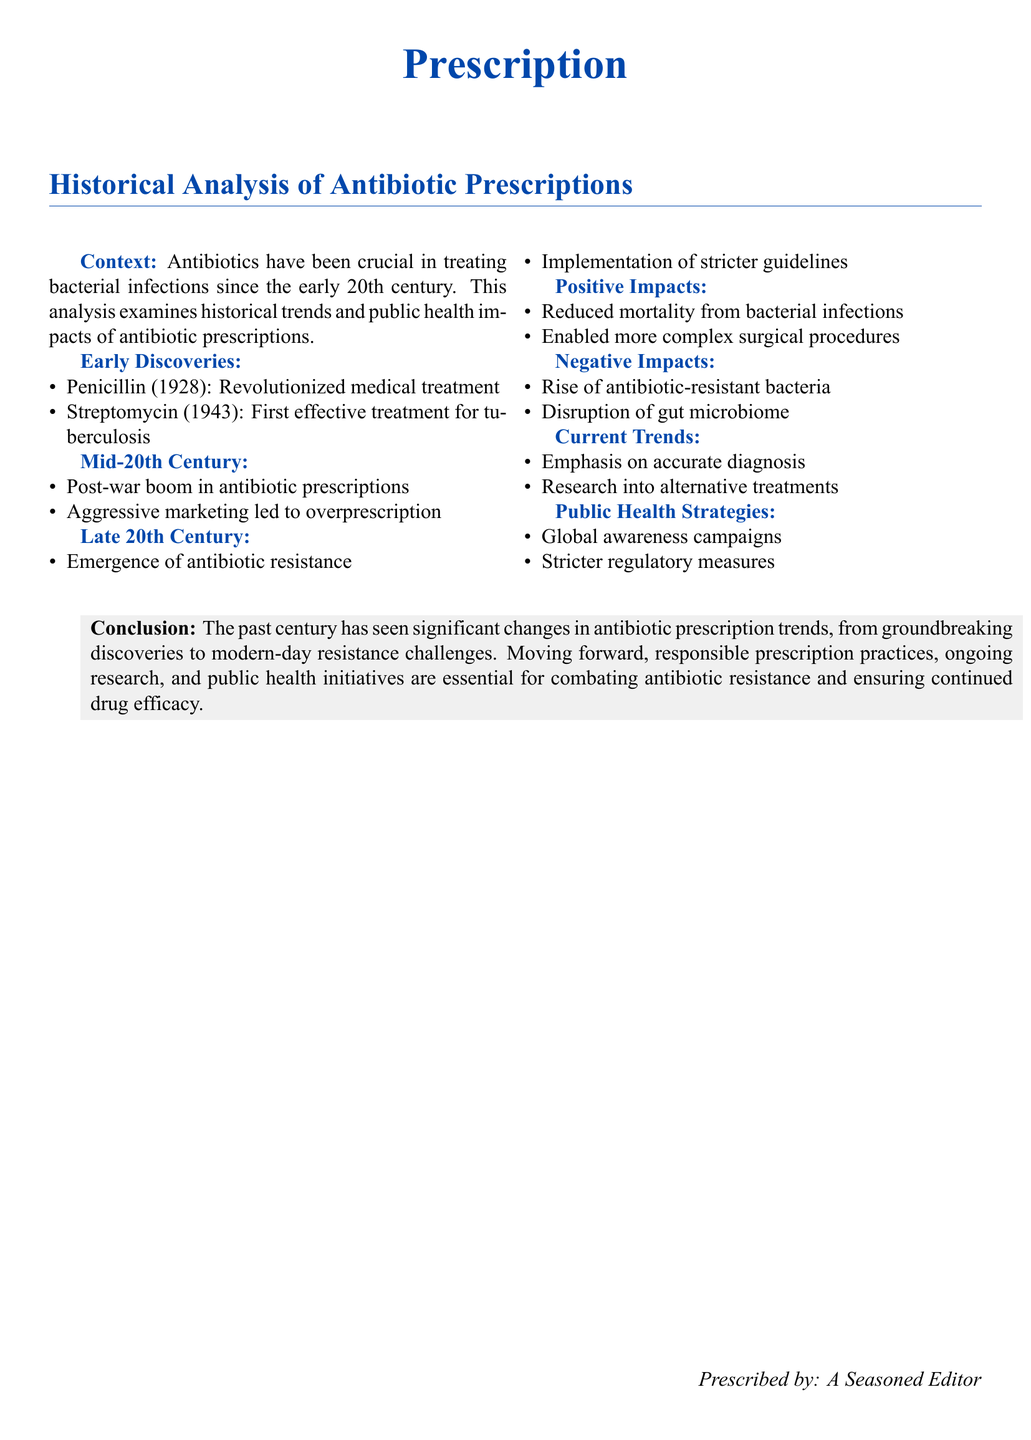What was the first antibiotic discovered? The document states that Penicillin was discovered in 1928, marking a significant breakthrough in medical treatment.
Answer: Penicillin What year was Streptomycin discovered? According to the document, Streptomycin, the first effective treatment for tuberculosis, was discovered in 1943.
Answer: 1943 What major issue emerged in the late 20th century concerning antibiotics? The document highlights the emergence of antibiotic resistance as a significant issue during this period.
Answer: Antibiotic resistance What was one positive impact of antibiotic prescriptions? The document notes that one positive impact was the reduction of mortality from bacterial infections.
Answer: Reduced mortality What do current trends emphasize in antibiotic prescriptions? The analysis mentions that current trends focus on accurate diagnosis.
Answer: Accurate diagnosis What marketing trend contributed to antibiotic overprescription in the mid-20th century? Aggressive marketing is identified in the document as a contributing factor to the overprescription of antibiotics.
Answer: Aggressive marketing What public health strategy is mentioned in the document to combat antibiotic resistance? The document refers to global awareness campaigns as one of the strategies being implemented.
Answer: Global awareness campaigns What recommendation does the conclusion make regarding the future of antibiotic prescriptions? The conclusion urges for responsible prescription practices as essential for combating resistance.
Answer: Responsible prescription practices 